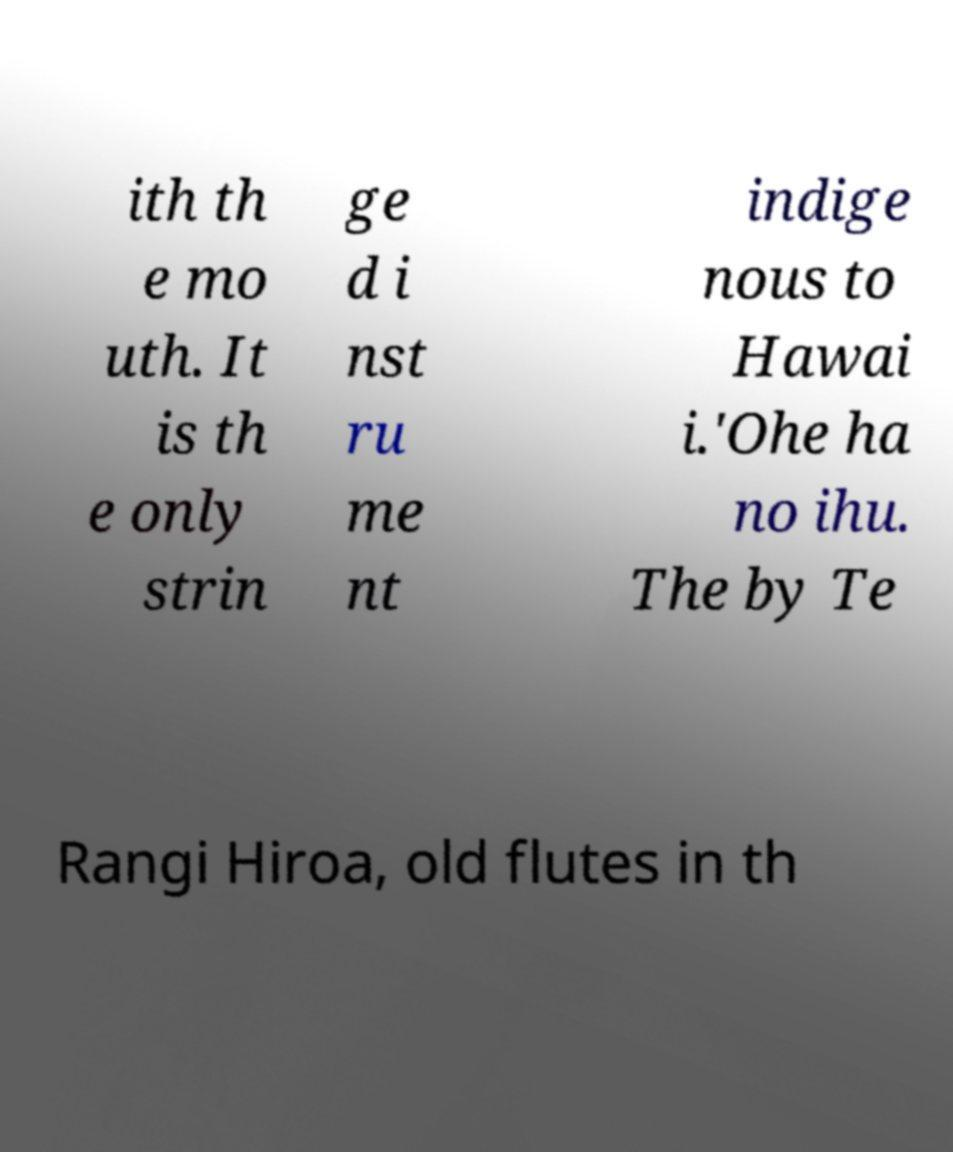What messages or text are displayed in this image? I need them in a readable, typed format. ith th e mo uth. It is th e only strin ge d i nst ru me nt indige nous to Hawai i.'Ohe ha no ihu. The by Te Rangi Hiroa, old flutes in th 